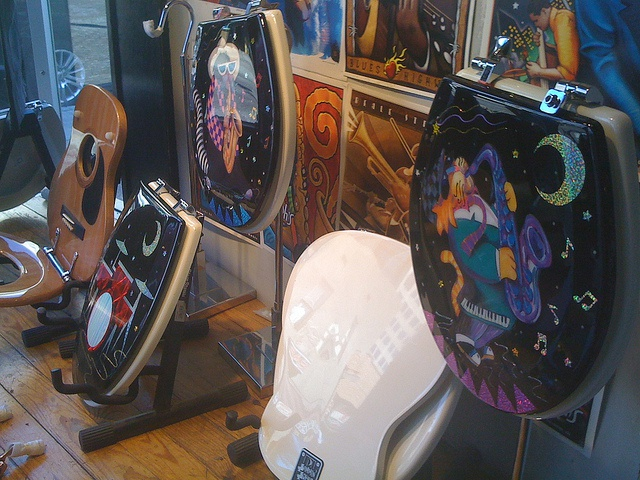Describe the objects in this image and their specific colors. I can see toilet in darkblue, black, navy, gray, and blue tones, toilet in darkblue, lightgray, darkgray, and gray tones, toilet in darkblue, black, gray, and darkgray tones, toilet in darkblue, black, gray, maroon, and darkgray tones, and toilet in darkblue, gray, brown, and black tones in this image. 